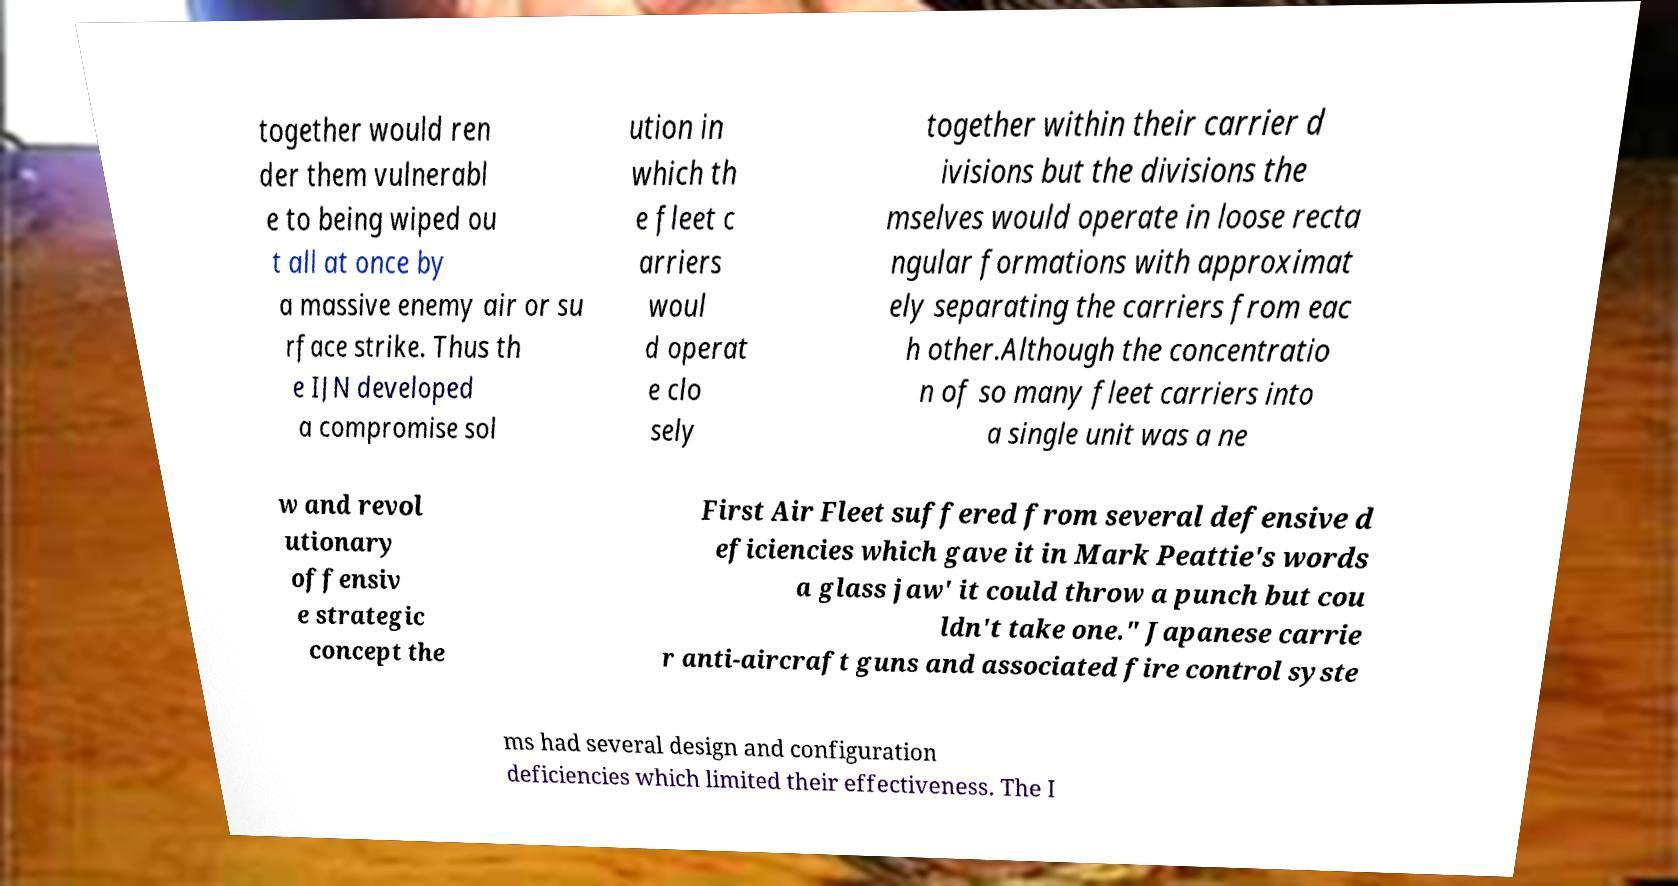For documentation purposes, I need the text within this image transcribed. Could you provide that? together would ren der them vulnerabl e to being wiped ou t all at once by a massive enemy air or su rface strike. Thus th e IJN developed a compromise sol ution in which th e fleet c arriers woul d operat e clo sely together within their carrier d ivisions but the divisions the mselves would operate in loose recta ngular formations with approximat ely separating the carriers from eac h other.Although the concentratio n of so many fleet carriers into a single unit was a ne w and revol utionary offensiv e strategic concept the First Air Fleet suffered from several defensive d eficiencies which gave it in Mark Peattie's words a glass jaw' it could throw a punch but cou ldn't take one." Japanese carrie r anti-aircraft guns and associated fire control syste ms had several design and configuration deficiencies which limited their effectiveness. The I 